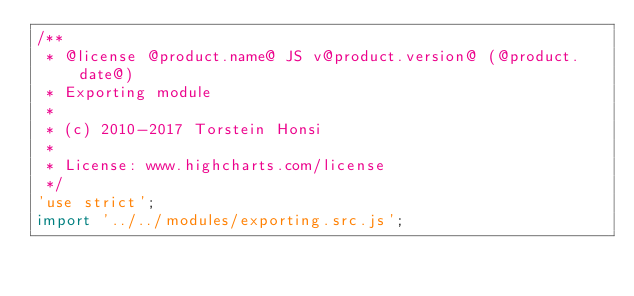<code> <loc_0><loc_0><loc_500><loc_500><_JavaScript_>/**
 * @license @product.name@ JS v@product.version@ (@product.date@)
 * Exporting module
 *
 * (c) 2010-2017 Torstein Honsi
 *
 * License: www.highcharts.com/license
 */
'use strict';
import '../../modules/exporting.src.js';
</code> 